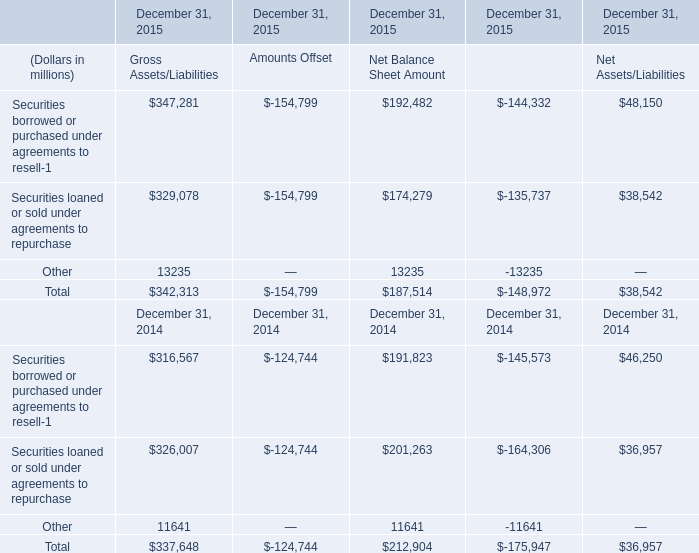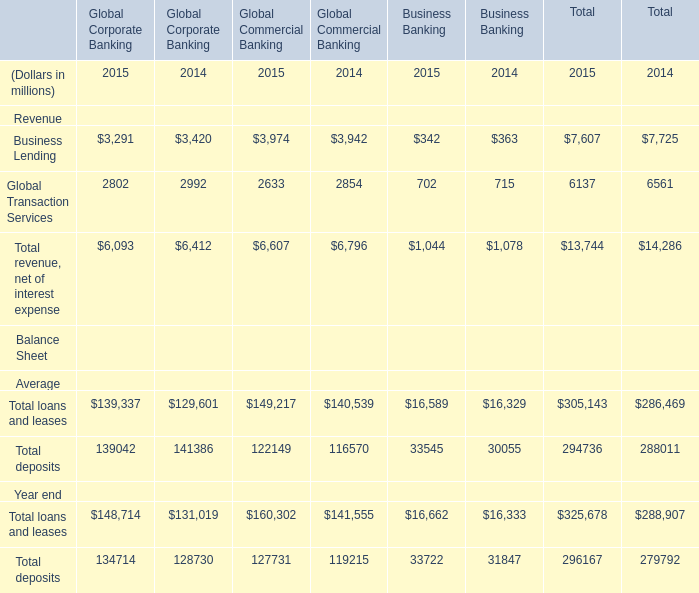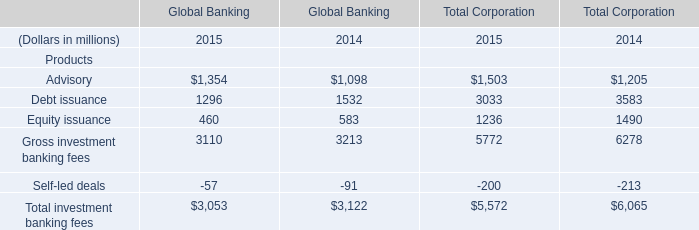What's the average of Gross investment banking fees in 2015 and 2014? (in millions) 
Computations: ((3110 + 3213) / 2)
Answer: 3161.5. 